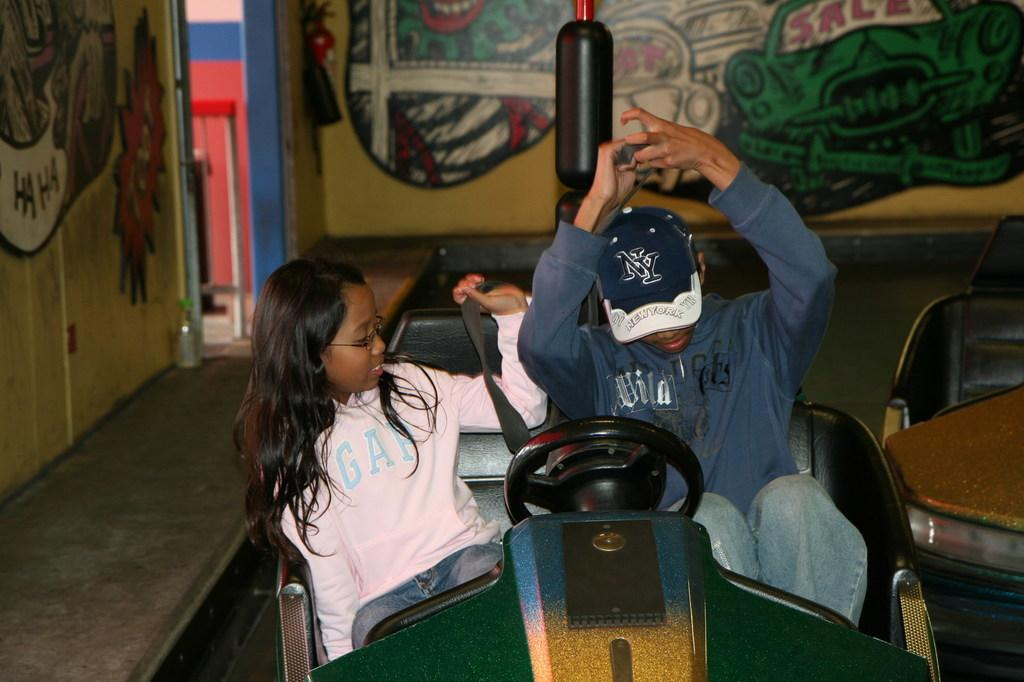<image>
Create a compact narrative representing the image presented. A man, sitting next to a girl, wears a hat with the initials NY. 